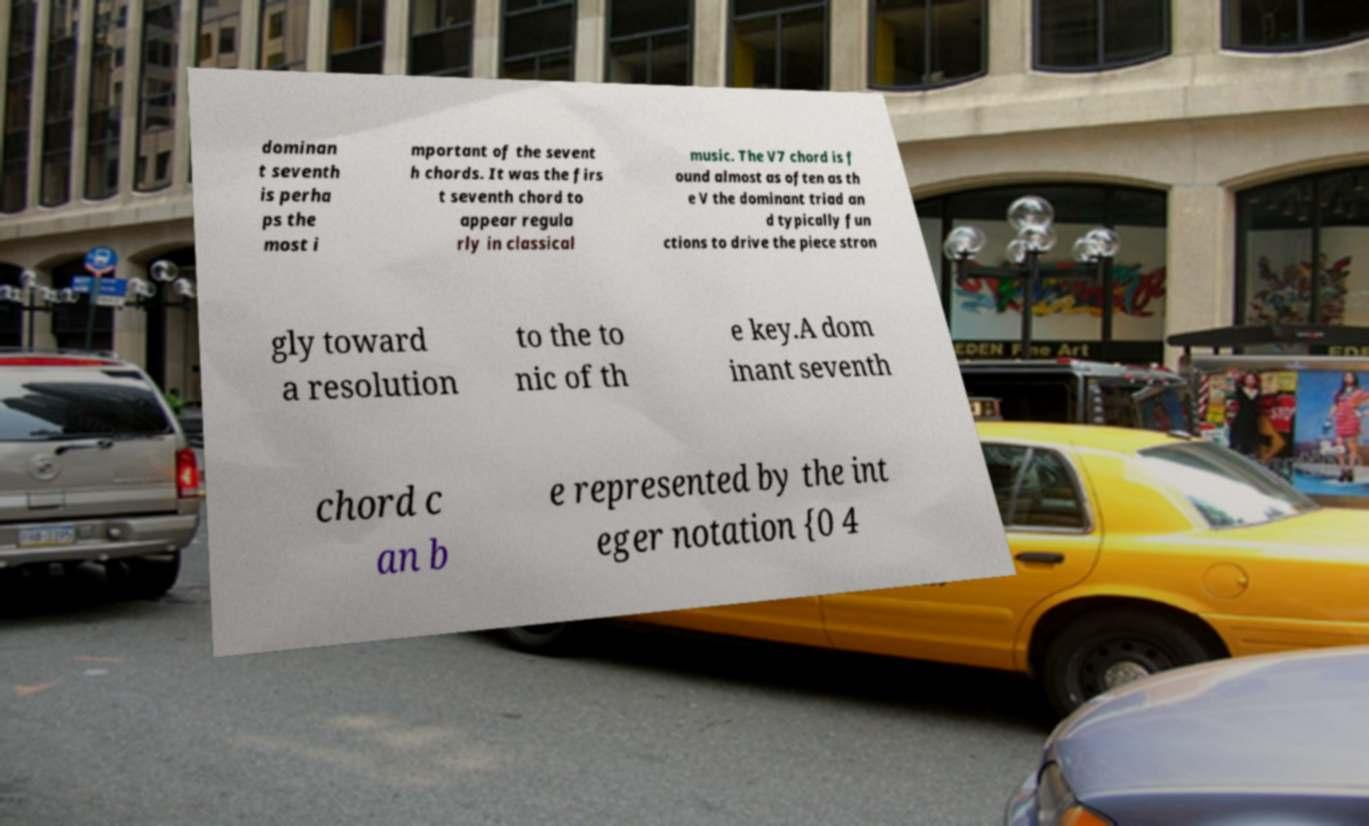Please read and relay the text visible in this image. What does it say? dominan t seventh is perha ps the most i mportant of the sevent h chords. It was the firs t seventh chord to appear regula rly in classical music. The V7 chord is f ound almost as often as th e V the dominant triad an d typically fun ctions to drive the piece stron gly toward a resolution to the to nic of th e key.A dom inant seventh chord c an b e represented by the int eger notation {0 4 